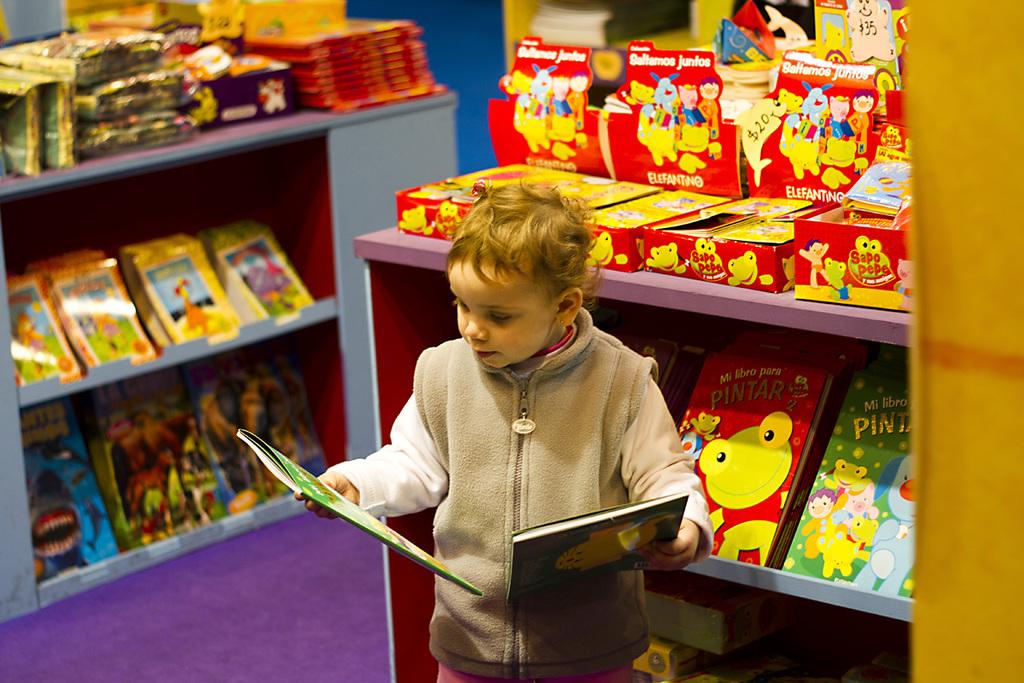Are these children books?
Give a very brief answer. Yes. What is the title of the book with the frog?
Ensure brevity in your answer.  Mi libro para pintar. 